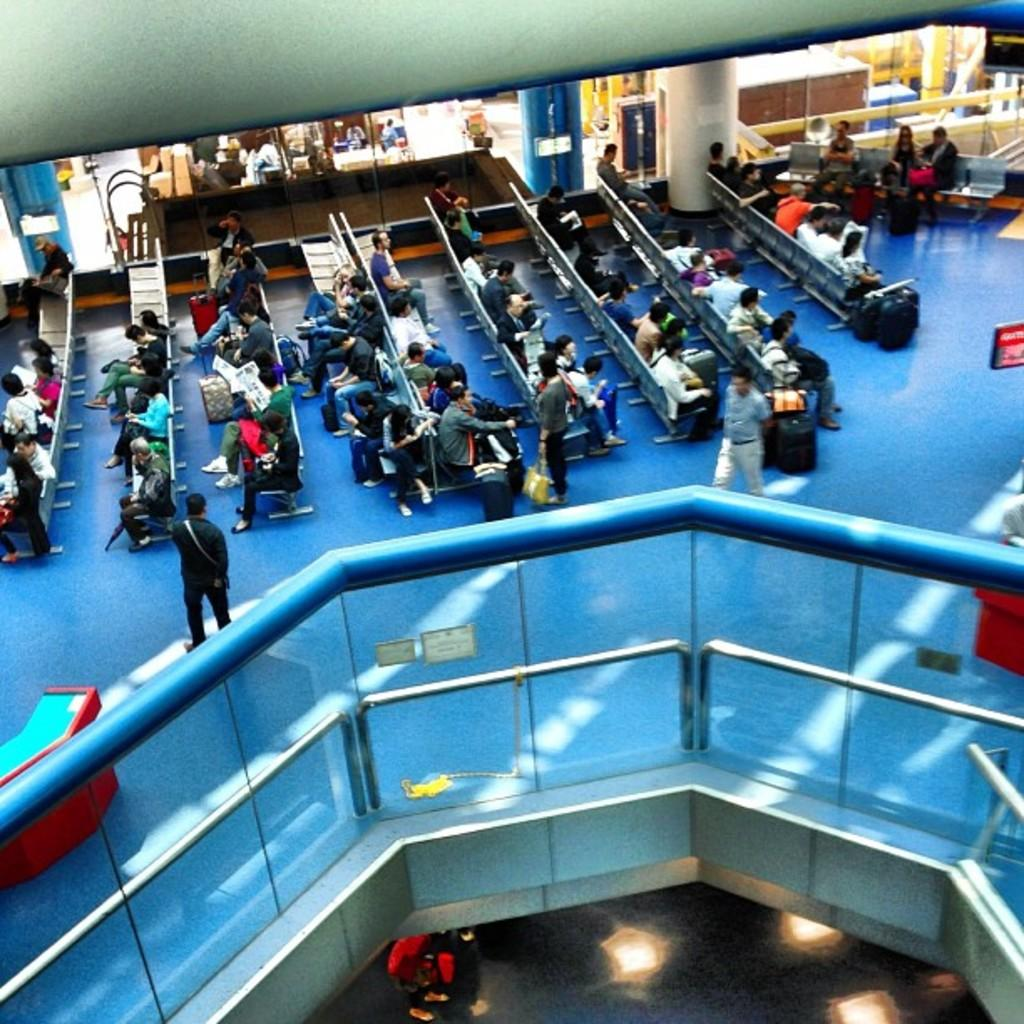How many people are in the image? There are people in the image, but the exact number is not specified. What are some people doing in the image? Some people are sitting on chairs, and some are holding bags. What can be seen near the people in the image? There is a grill, windows, poles, posters, and a table in the image. What type of tree is growing through the table in the image? There is no tree growing through the table in the image; it is not mentioned in the facts. What ideas are being discussed by the people in the image? The facts do not provide any information about the conversations or ideas being discussed by the people in the image. 